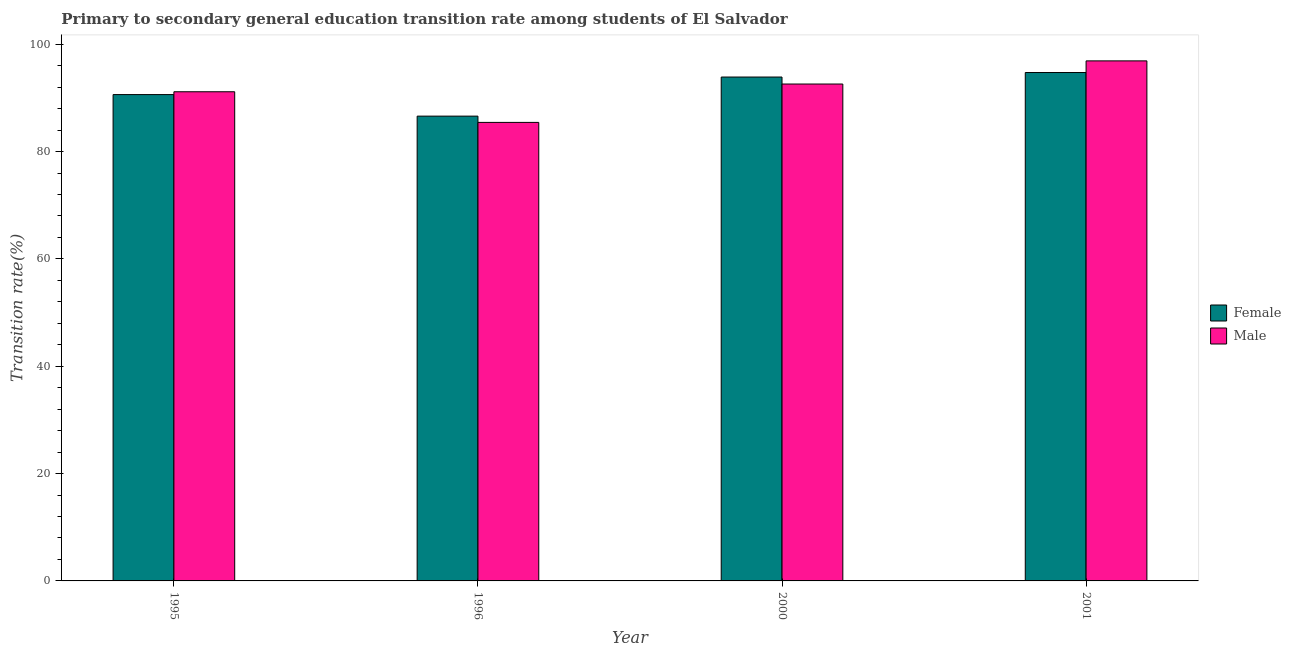How many groups of bars are there?
Ensure brevity in your answer.  4. What is the label of the 4th group of bars from the left?
Offer a terse response. 2001. In how many cases, is the number of bars for a given year not equal to the number of legend labels?
Offer a very short reply. 0. What is the transition rate among female students in 2001?
Offer a terse response. 94.73. Across all years, what is the maximum transition rate among female students?
Keep it short and to the point. 94.73. Across all years, what is the minimum transition rate among female students?
Make the answer very short. 86.6. What is the total transition rate among female students in the graph?
Provide a succinct answer. 365.84. What is the difference between the transition rate among female students in 1995 and that in 2000?
Your answer should be compact. -3.27. What is the difference between the transition rate among female students in 1995 and the transition rate among male students in 2000?
Your response must be concise. -3.27. What is the average transition rate among female students per year?
Offer a very short reply. 91.46. In how many years, is the transition rate among female students greater than 72 %?
Give a very brief answer. 4. What is the ratio of the transition rate among male students in 1995 to that in 1996?
Offer a terse response. 1.07. Is the transition rate among male students in 2000 less than that in 2001?
Your response must be concise. Yes. Is the difference between the transition rate among female students in 2000 and 2001 greater than the difference between the transition rate among male students in 2000 and 2001?
Ensure brevity in your answer.  No. What is the difference between the highest and the second highest transition rate among female students?
Offer a terse response. 0.84. What is the difference between the highest and the lowest transition rate among female students?
Keep it short and to the point. 8.13. Is the sum of the transition rate among male students in 1995 and 2001 greater than the maximum transition rate among female students across all years?
Your answer should be compact. Yes. How many bars are there?
Offer a terse response. 8. Are all the bars in the graph horizontal?
Keep it short and to the point. No. Are the values on the major ticks of Y-axis written in scientific E-notation?
Your answer should be compact. No. Where does the legend appear in the graph?
Give a very brief answer. Center right. How many legend labels are there?
Your answer should be compact. 2. How are the legend labels stacked?
Provide a succinct answer. Vertical. What is the title of the graph?
Your response must be concise. Primary to secondary general education transition rate among students of El Salvador. What is the label or title of the X-axis?
Keep it short and to the point. Year. What is the label or title of the Y-axis?
Provide a succinct answer. Transition rate(%). What is the Transition rate(%) in Female in 1995?
Offer a very short reply. 90.62. What is the Transition rate(%) in Male in 1995?
Ensure brevity in your answer.  91.15. What is the Transition rate(%) in Female in 1996?
Offer a very short reply. 86.6. What is the Transition rate(%) of Male in 1996?
Your answer should be very brief. 85.43. What is the Transition rate(%) of Female in 2000?
Your answer should be compact. 93.89. What is the Transition rate(%) of Male in 2000?
Keep it short and to the point. 92.58. What is the Transition rate(%) in Female in 2001?
Offer a very short reply. 94.73. What is the Transition rate(%) of Male in 2001?
Make the answer very short. 96.9. Across all years, what is the maximum Transition rate(%) of Female?
Provide a short and direct response. 94.73. Across all years, what is the maximum Transition rate(%) of Male?
Offer a terse response. 96.9. Across all years, what is the minimum Transition rate(%) of Female?
Provide a succinct answer. 86.6. Across all years, what is the minimum Transition rate(%) of Male?
Offer a terse response. 85.43. What is the total Transition rate(%) of Female in the graph?
Keep it short and to the point. 365.84. What is the total Transition rate(%) in Male in the graph?
Keep it short and to the point. 366.06. What is the difference between the Transition rate(%) in Female in 1995 and that in 1996?
Keep it short and to the point. 4.01. What is the difference between the Transition rate(%) in Male in 1995 and that in 1996?
Ensure brevity in your answer.  5.71. What is the difference between the Transition rate(%) of Female in 1995 and that in 2000?
Give a very brief answer. -3.27. What is the difference between the Transition rate(%) of Male in 1995 and that in 2000?
Your answer should be very brief. -1.44. What is the difference between the Transition rate(%) of Female in 1995 and that in 2001?
Give a very brief answer. -4.11. What is the difference between the Transition rate(%) in Male in 1995 and that in 2001?
Your answer should be very brief. -5.75. What is the difference between the Transition rate(%) of Female in 1996 and that in 2000?
Provide a short and direct response. -7.28. What is the difference between the Transition rate(%) in Male in 1996 and that in 2000?
Keep it short and to the point. -7.15. What is the difference between the Transition rate(%) in Female in 1996 and that in 2001?
Make the answer very short. -8.13. What is the difference between the Transition rate(%) in Male in 1996 and that in 2001?
Make the answer very short. -11.46. What is the difference between the Transition rate(%) of Female in 2000 and that in 2001?
Your response must be concise. -0.84. What is the difference between the Transition rate(%) in Male in 2000 and that in 2001?
Offer a very short reply. -4.31. What is the difference between the Transition rate(%) in Female in 1995 and the Transition rate(%) in Male in 1996?
Your answer should be very brief. 5.18. What is the difference between the Transition rate(%) of Female in 1995 and the Transition rate(%) of Male in 2000?
Offer a terse response. -1.97. What is the difference between the Transition rate(%) of Female in 1995 and the Transition rate(%) of Male in 2001?
Your answer should be compact. -6.28. What is the difference between the Transition rate(%) of Female in 1996 and the Transition rate(%) of Male in 2000?
Your answer should be very brief. -5.98. What is the difference between the Transition rate(%) in Female in 1996 and the Transition rate(%) in Male in 2001?
Your response must be concise. -10.29. What is the difference between the Transition rate(%) of Female in 2000 and the Transition rate(%) of Male in 2001?
Offer a terse response. -3.01. What is the average Transition rate(%) of Female per year?
Offer a very short reply. 91.46. What is the average Transition rate(%) of Male per year?
Ensure brevity in your answer.  91.52. In the year 1995, what is the difference between the Transition rate(%) of Female and Transition rate(%) of Male?
Ensure brevity in your answer.  -0.53. In the year 1996, what is the difference between the Transition rate(%) in Female and Transition rate(%) in Male?
Your answer should be compact. 1.17. In the year 2000, what is the difference between the Transition rate(%) in Female and Transition rate(%) in Male?
Provide a short and direct response. 1.3. In the year 2001, what is the difference between the Transition rate(%) of Female and Transition rate(%) of Male?
Your response must be concise. -2.17. What is the ratio of the Transition rate(%) of Female in 1995 to that in 1996?
Give a very brief answer. 1.05. What is the ratio of the Transition rate(%) in Male in 1995 to that in 1996?
Ensure brevity in your answer.  1.07. What is the ratio of the Transition rate(%) in Female in 1995 to that in 2000?
Keep it short and to the point. 0.97. What is the ratio of the Transition rate(%) of Male in 1995 to that in 2000?
Give a very brief answer. 0.98. What is the ratio of the Transition rate(%) of Female in 1995 to that in 2001?
Your answer should be compact. 0.96. What is the ratio of the Transition rate(%) of Male in 1995 to that in 2001?
Your response must be concise. 0.94. What is the ratio of the Transition rate(%) in Female in 1996 to that in 2000?
Offer a terse response. 0.92. What is the ratio of the Transition rate(%) in Male in 1996 to that in 2000?
Make the answer very short. 0.92. What is the ratio of the Transition rate(%) in Female in 1996 to that in 2001?
Provide a succinct answer. 0.91. What is the ratio of the Transition rate(%) of Male in 1996 to that in 2001?
Give a very brief answer. 0.88. What is the ratio of the Transition rate(%) of Female in 2000 to that in 2001?
Keep it short and to the point. 0.99. What is the ratio of the Transition rate(%) of Male in 2000 to that in 2001?
Offer a very short reply. 0.96. What is the difference between the highest and the second highest Transition rate(%) of Female?
Make the answer very short. 0.84. What is the difference between the highest and the second highest Transition rate(%) of Male?
Provide a succinct answer. 4.31. What is the difference between the highest and the lowest Transition rate(%) of Female?
Ensure brevity in your answer.  8.13. What is the difference between the highest and the lowest Transition rate(%) in Male?
Your answer should be compact. 11.46. 